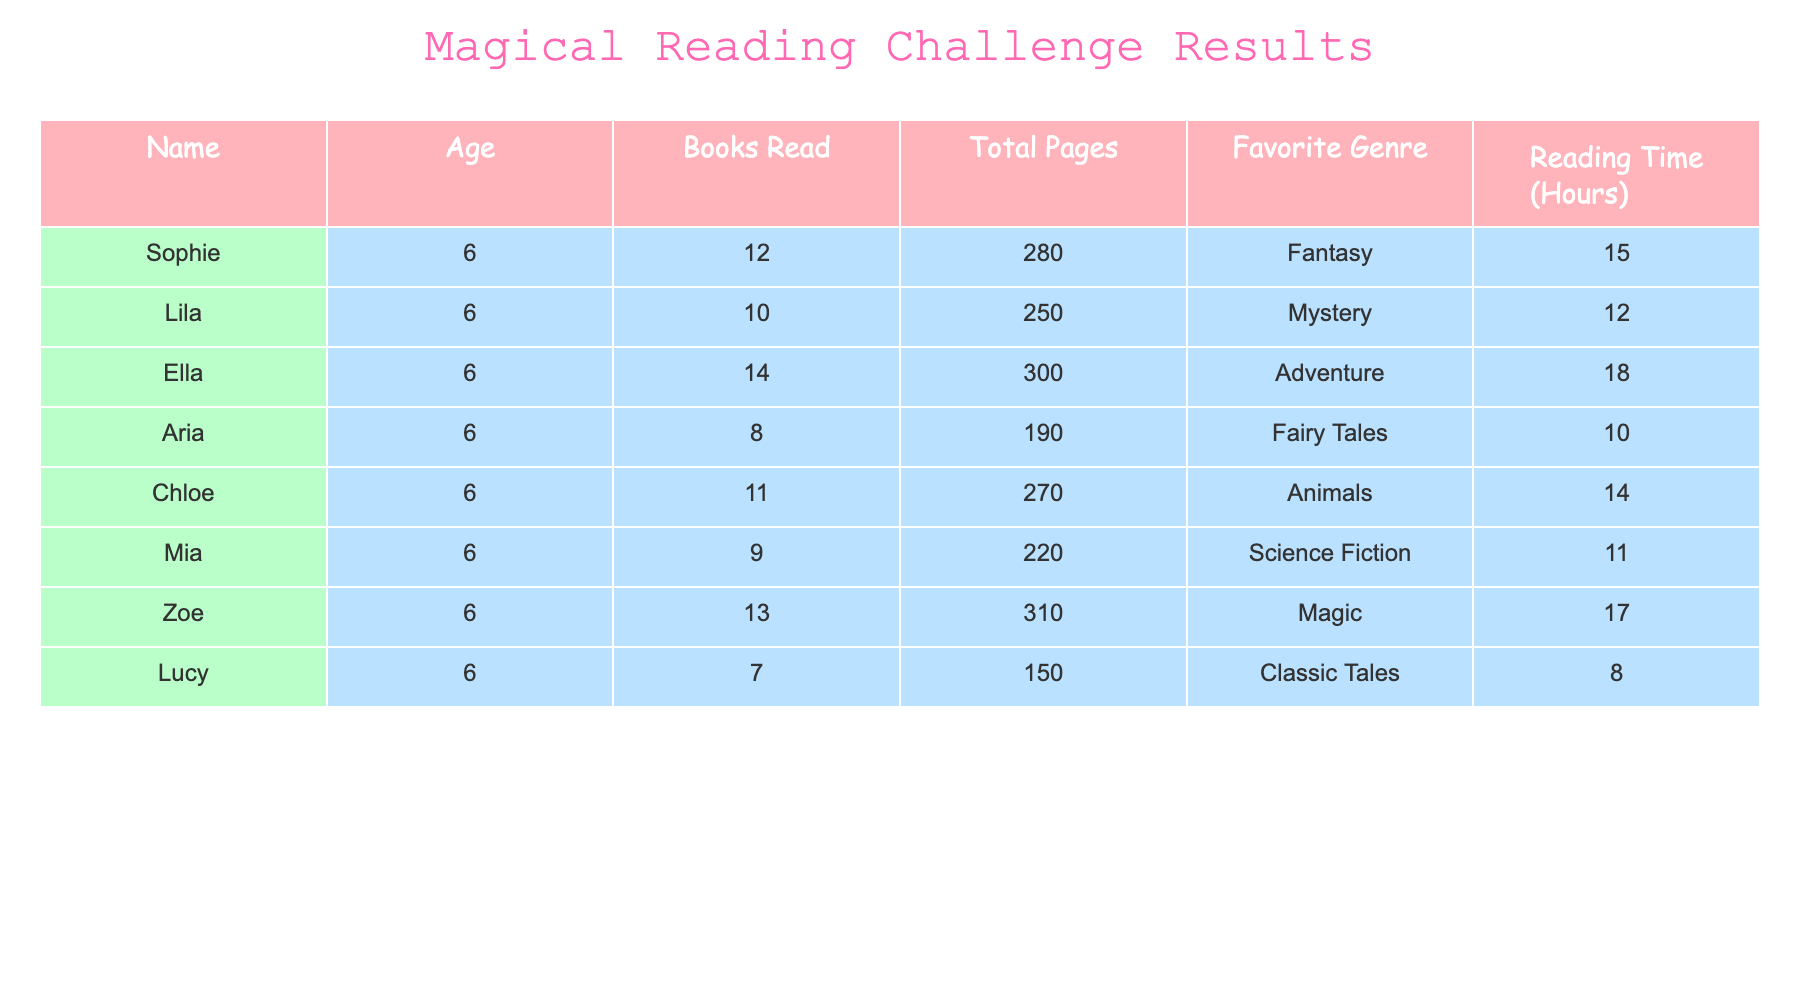What is the name of the student who read the most books? Looking at the "Books Read" column, Ella has read 14 books, which is more than any other student listed in the table.
Answer: Ella How many total pages did Zoe read? From the "Total Pages" column, Zoe read a total of 310 pages.
Answer: 310 Which genre was most popular among the students? By counting the occurrences in the "Favorite Genre" column, we can see that Adventure, Fantasy, and Magic each have a unique popularity. However, the most represented genre is Fantasy by Sophie and Zoe who have expressed a preference for it, combined with others looking at their different options.
Answer: Fantasy What is the average number of books read by the students? We add the total number of books read: (12 + 10 + 14 + 8 + 11 + 9 + 13 + 7) = 94. There are 8 students, so we divide: 94 / 8 = 11.75.
Answer: 11.75 Did Mia read more books than Aria? By comparing the "Books Read" values, Mia read 9 books while Aria read 8 books. Since 9 is greater than 8, the statement is true.
Answer: Yes What is the total reading time for all students combined? To find the total reading time, we sum the "Reading Time" column: (15 + 12 + 18 + 10 + 14 + 11 + 17 + 8) = 105 hours.
Answer: 105 hours Who has the highest reading time, and how many hours did they spend reading? Looking at the "Reading Time" column, Ella has the highest reading time of 18 hours, which is greater than all the other students' times.
Answer: Ella, 18 hours What is the difference between the most pages read and the least pages read? The most pages read is Zoe with 310 pages and the least is Lucy with 150 pages. The difference is 310 - 150 = 160 pages.
Answer: 160 pages 